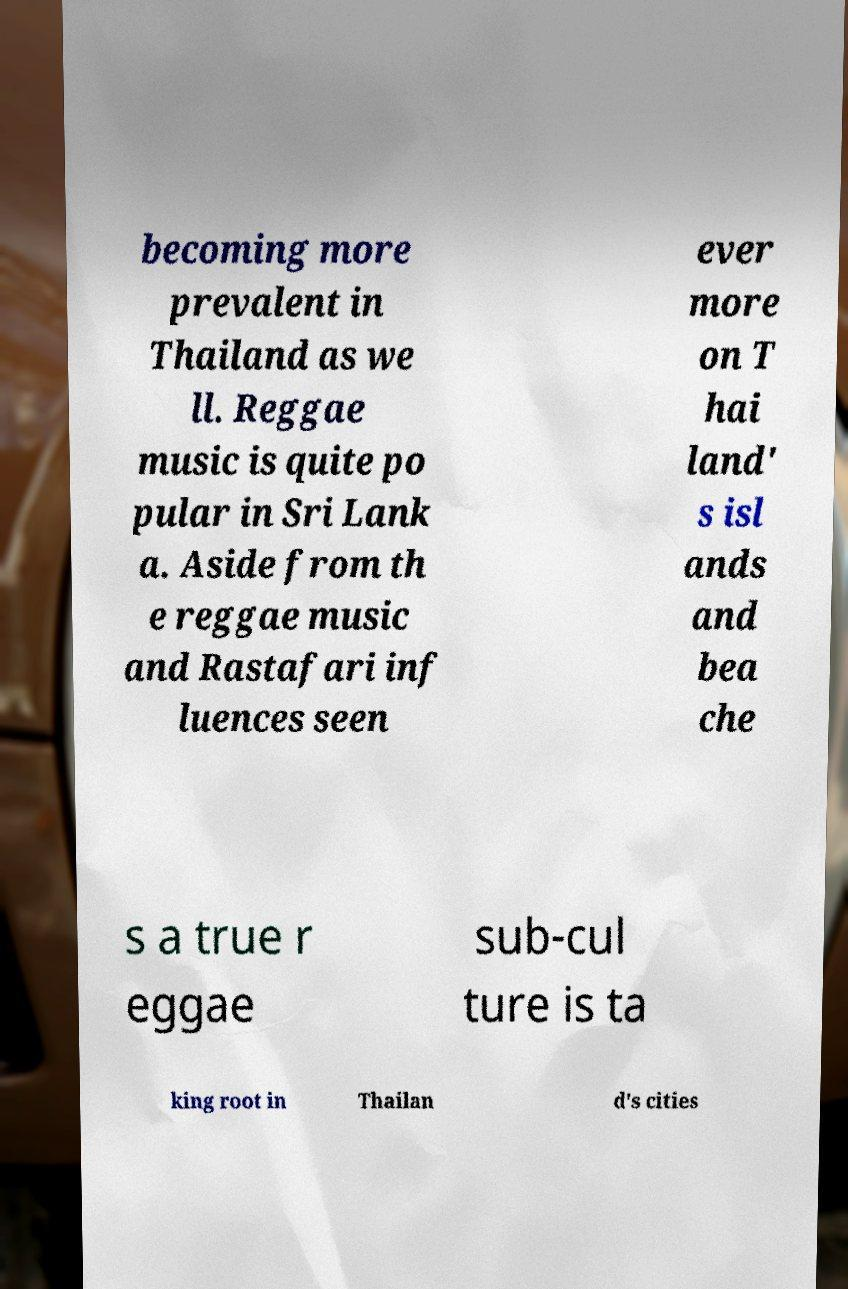For documentation purposes, I need the text within this image transcribed. Could you provide that? becoming more prevalent in Thailand as we ll. Reggae music is quite po pular in Sri Lank a. Aside from th e reggae music and Rastafari inf luences seen ever more on T hai land' s isl ands and bea che s a true r eggae sub-cul ture is ta king root in Thailan d's cities 